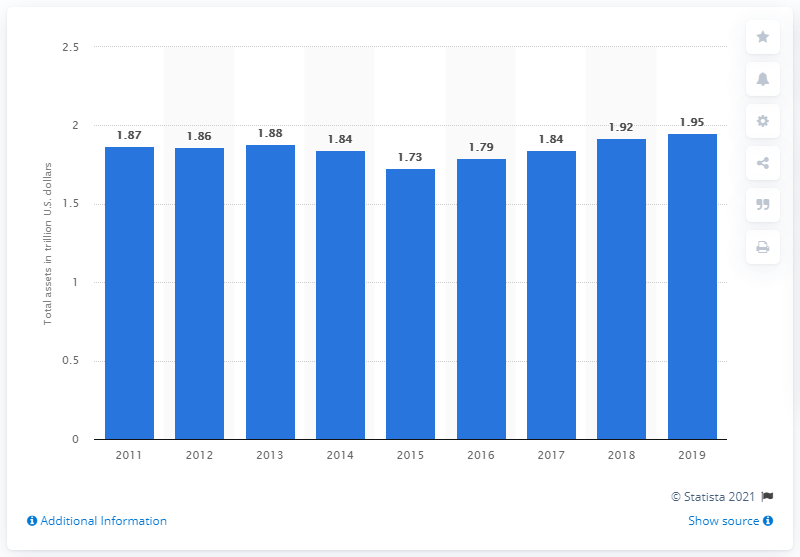Mention a couple of crucial points in this snapshot. In 2019, the total assets of Citigroup were approximately 1.95 trillion dollars. 